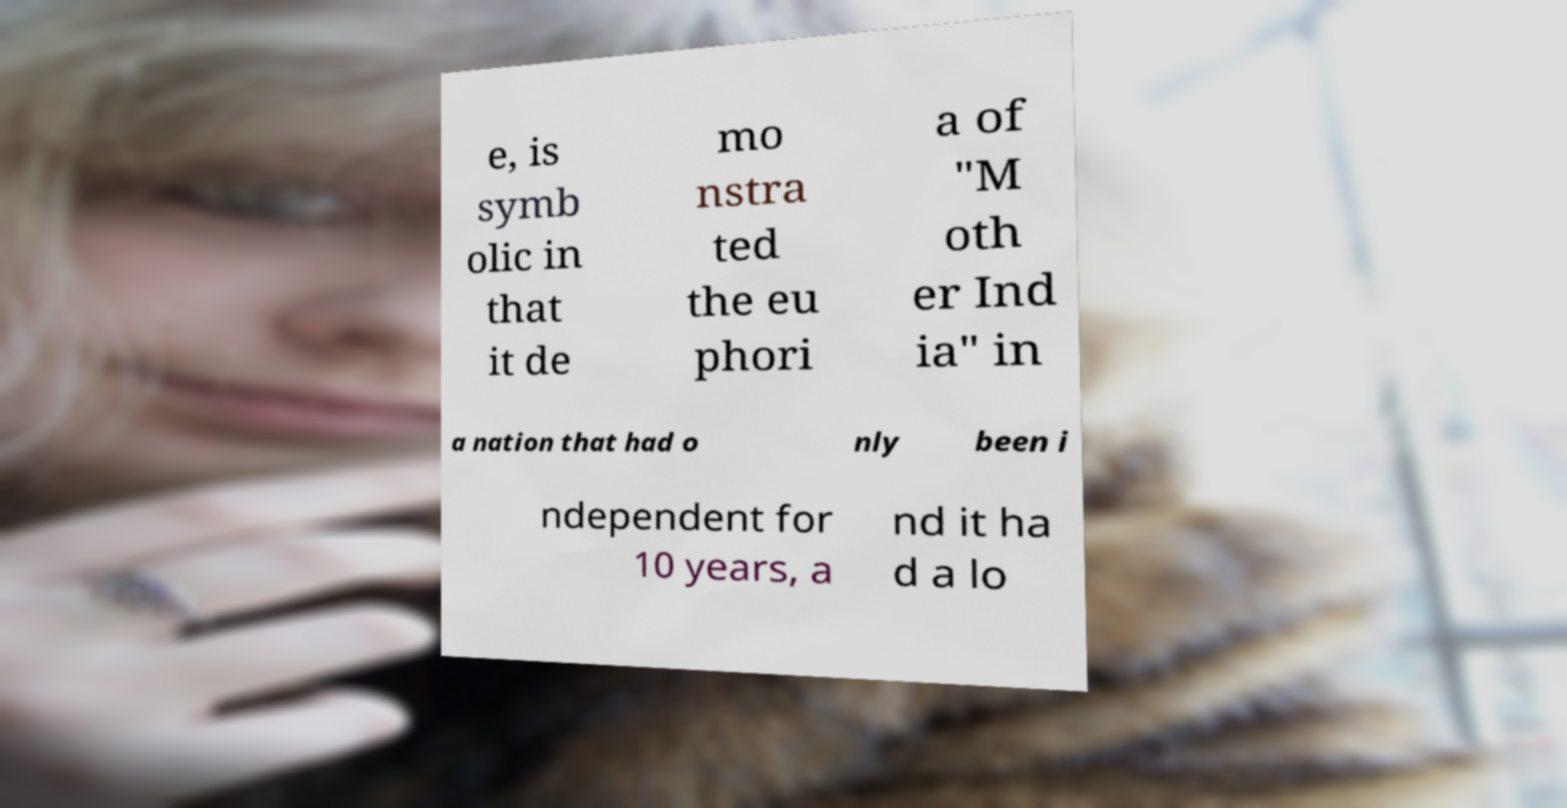Can you read and provide the text displayed in the image?This photo seems to have some interesting text. Can you extract and type it out for me? e, is symb olic in that it de mo nstra ted the eu phori a of "M oth er Ind ia" in a nation that had o nly been i ndependent for 10 years, a nd it ha d a lo 